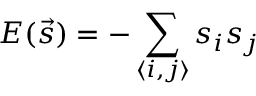Convert formula to latex. <formula><loc_0><loc_0><loc_500><loc_500>E ( \vec { s } ) = - \sum _ { \langle i , j \rangle } s _ { i } s _ { j }</formula> 